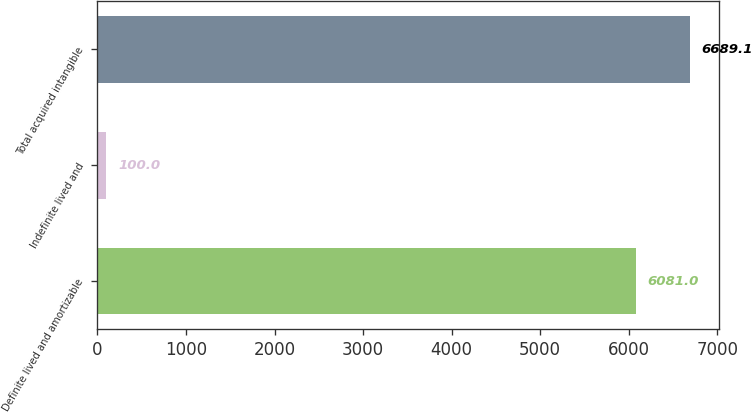Convert chart. <chart><loc_0><loc_0><loc_500><loc_500><bar_chart><fcel>Definite lived and amortizable<fcel>Indefinite lived and<fcel>Total acquired intangible<nl><fcel>6081<fcel>100<fcel>6689.1<nl></chart> 